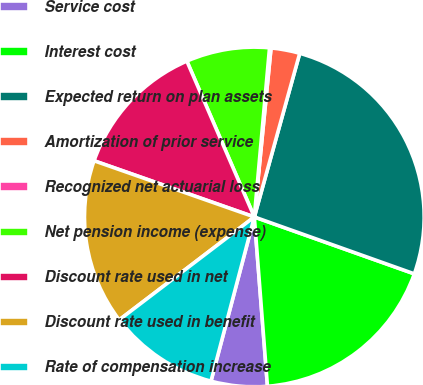<chart> <loc_0><loc_0><loc_500><loc_500><pie_chart><fcel>Service cost<fcel>Interest cost<fcel>Expected return on plan assets<fcel>Amortization of prior service<fcel>Recognized net actuarial loss<fcel>Net pension income (expense)<fcel>Discount rate used in net<fcel>Discount rate used in benefit<fcel>Rate of compensation increase<nl><fcel>5.34%<fcel>18.33%<fcel>26.13%<fcel>2.74%<fcel>0.14%<fcel>7.93%<fcel>13.13%<fcel>15.73%<fcel>10.53%<nl></chart> 